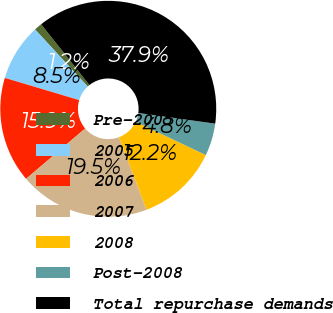Convert chart. <chart><loc_0><loc_0><loc_500><loc_500><pie_chart><fcel>Pre-2005<fcel>2005<fcel>2006<fcel>2007<fcel>2008<fcel>Post-2008<fcel>Total repurchase demands<nl><fcel>1.18%<fcel>8.52%<fcel>15.86%<fcel>19.53%<fcel>12.19%<fcel>4.85%<fcel>37.88%<nl></chart> 